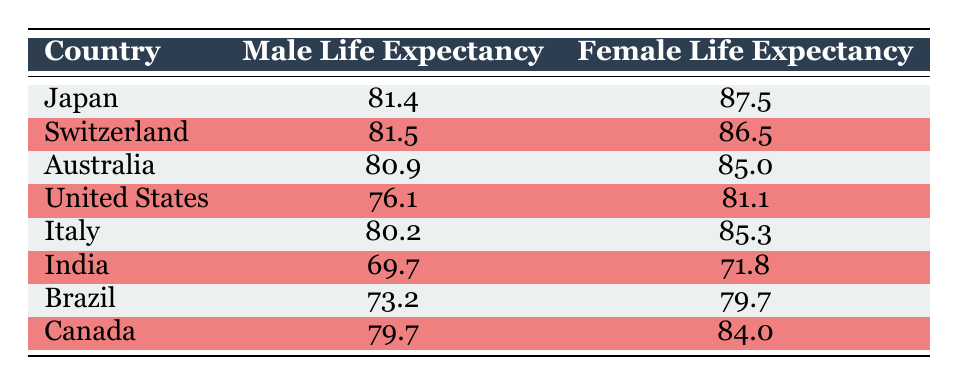What is the life expectancy of females in Japan? The table shows that the female life expectancy in Japan is 87.5.
Answer: 87.5 Which country has the lowest male life expectancy? According to the table, India has the lowest male life expectancy at 69.7.
Answer: India What is the difference between male and female life expectancy in the United States? The male life expectancy in the United States is 76.1 and the female life expectancy is 81.1. The difference is 81.1 - 76.1 = 5.0.
Answer: 5.0 Is the male life expectancy in Switzerland greater than in Australia? In Switzerland, the male life expectancy is 81.5 and in Australia it is 80.9. Therefore, yes, Switzerland's male life expectancy is greater than Australia's.
Answer: Yes What is the average female life expectancy among the countries listed? To find the average female life expectancy, sum the values: 87.5 + 86.5 + 85.0 + 81.1 + 85.3 + 71.8 + 79.7 + 84.0 =  85.6. Then divide by the number of countries, which is 8:  685.9 / 8 = 85.7375, which rounds to 85.7.
Answer: 85.7 Which country has the highest life expectancy for males? The highest male life expectancy is in Switzerland, which is 81.5.
Answer: Switzerland What is the combined male life expectancy of Japan and Canada? The male life expectancy in Japan is 81.4 and in Canada it is 79.7. Adding these together gives 81.4 + 79.7 = 161.1.
Answer: 161.1 Is it true that female life expectancy is greater than male life expectancy in all countries listed? Reviewing the table, Japan, Switzerland, Australia, Italy, and Canada have higher female life expectancies than males, but India and Brazil do not, hence the statement is false.
Answer: No What country has a male life expectancy that is more than 75 but less than 80? Looking at the table, Brazil has a male life expectancy of 73.2, which is less than 75. The countries above 75 are Australia (80.9), Italy (80.2), and Canada (79.7). Only Canada falls into this range; therefore, Canada is the answer.
Answer: Canada 